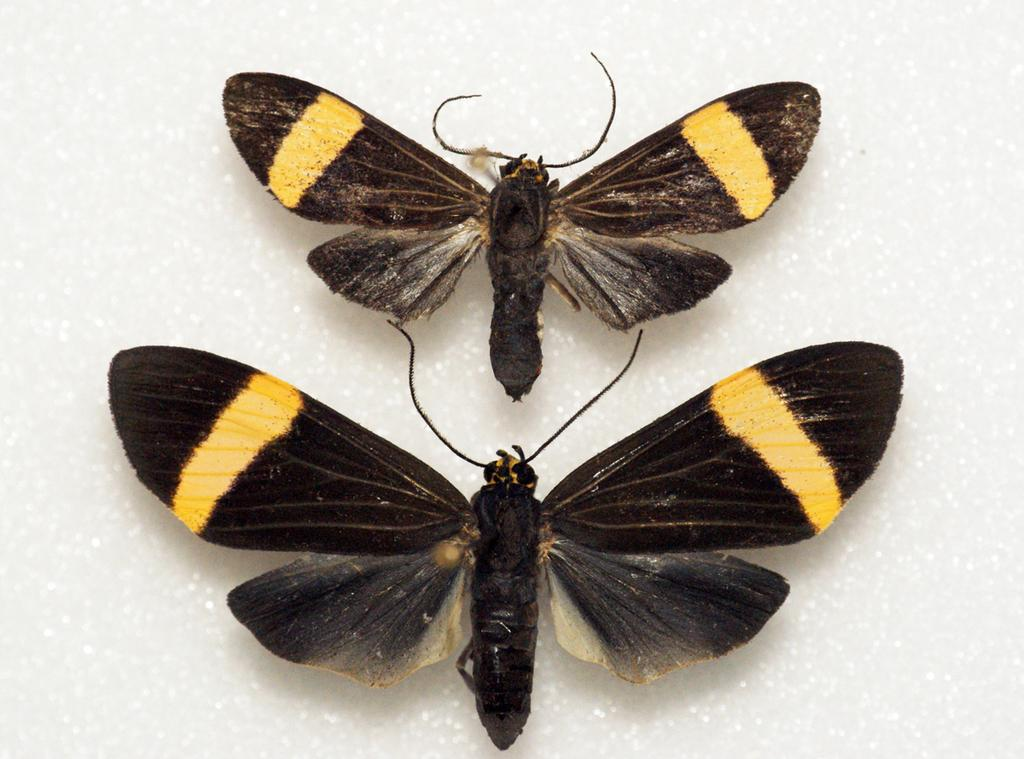How many butterflies are present in the image? There are two butterflies in the image. What colors can be seen on the butterflies? The butterflies have black and yellow colors. What is the color of the surface on which the butterflies are resting? The surface on which the butterflies are resting is white. What type of plot is being developed by the ladybug in the image? There is no ladybug present in the image, so no plot can be developed by a ladybug. 